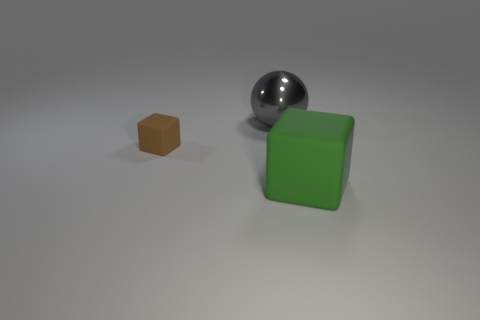Add 2 yellow shiny blocks. How many objects exist? 5 Subtract all blocks. How many objects are left? 1 Add 1 green rubber things. How many green rubber things exist? 2 Subtract 0 gray cubes. How many objects are left? 3 Subtract all large green blocks. Subtract all matte things. How many objects are left? 0 Add 2 spheres. How many spheres are left? 3 